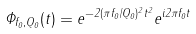Convert formula to latex. <formula><loc_0><loc_0><loc_500><loc_500>\Phi _ { f _ { 0 } , Q _ { 0 } } ( t ) = e ^ { - 2 ( \pi f _ { 0 } / Q _ { 0 } ) ^ { 2 } t ^ { 2 } } e ^ { i 2 \pi f _ { 0 } t }</formula> 